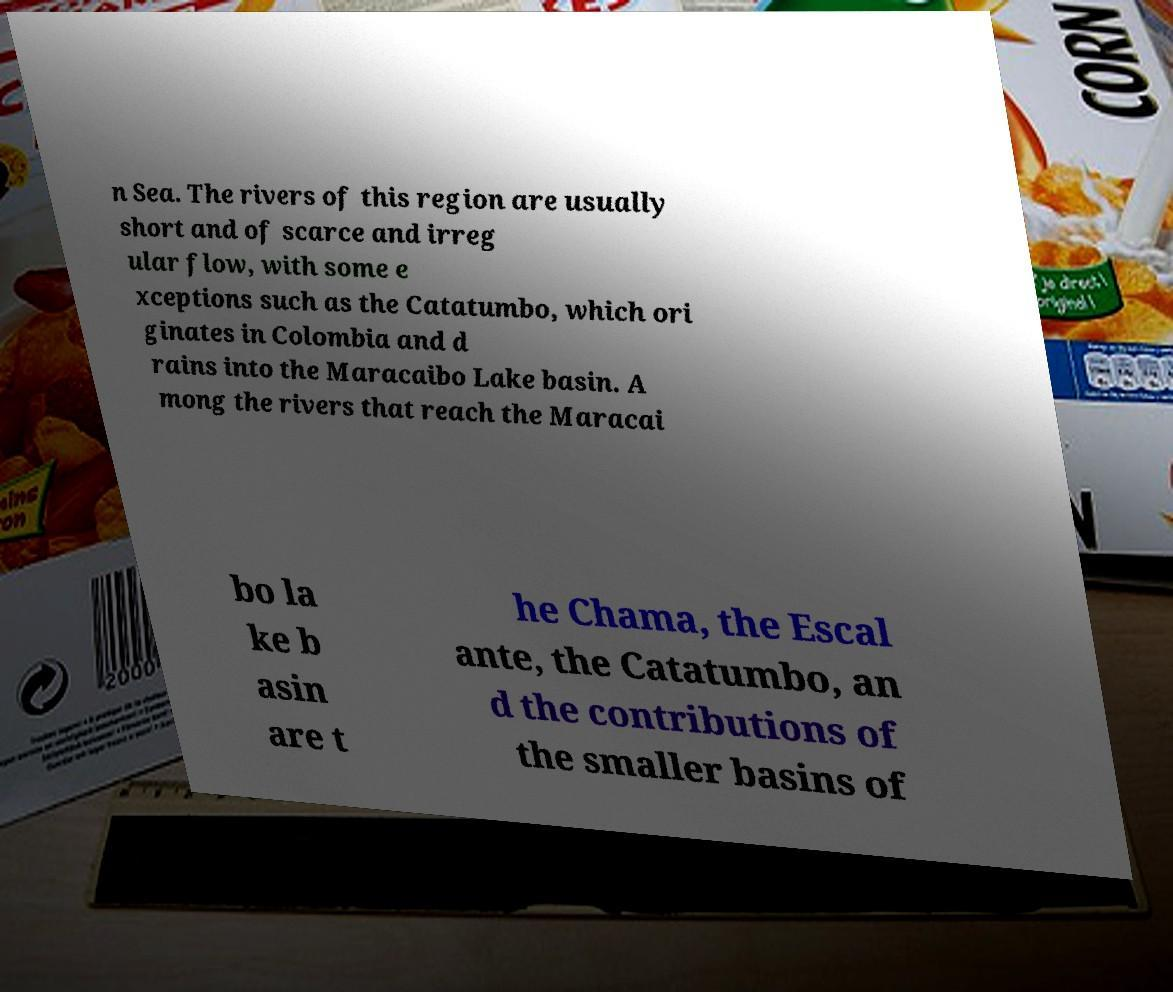Could you extract and type out the text from this image? n Sea. The rivers of this region are usually short and of scarce and irreg ular flow, with some e xceptions such as the Catatumbo, which ori ginates in Colombia and d rains into the Maracaibo Lake basin. A mong the rivers that reach the Maracai bo la ke b asin are t he Chama, the Escal ante, the Catatumbo, an d the contributions of the smaller basins of 